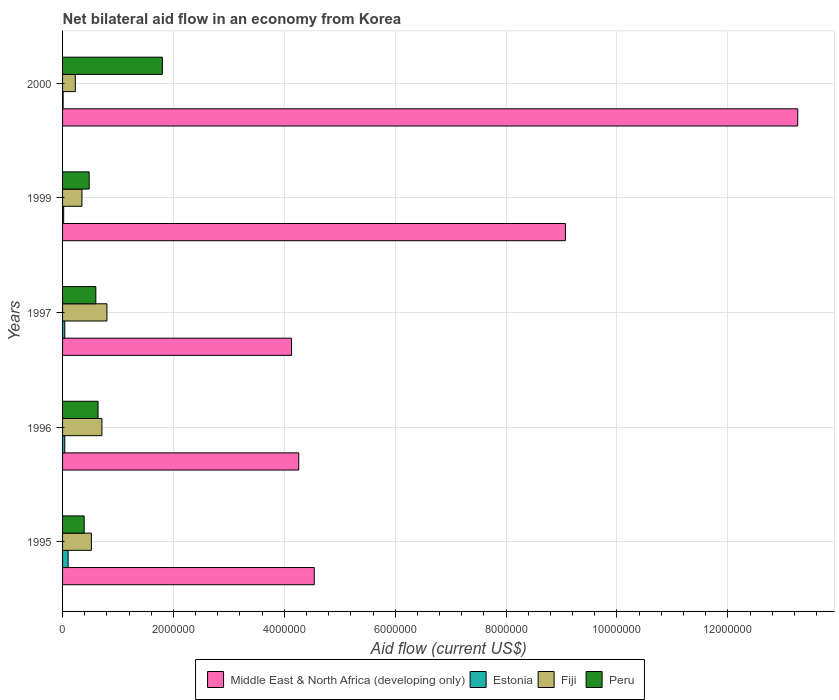How many groups of bars are there?
Your answer should be very brief. 5. Are the number of bars per tick equal to the number of legend labels?
Make the answer very short. Yes. Are the number of bars on each tick of the Y-axis equal?
Your answer should be very brief. Yes. How many bars are there on the 1st tick from the top?
Your answer should be very brief. 4. What is the label of the 4th group of bars from the top?
Keep it short and to the point. 1996. In how many cases, is the number of bars for a given year not equal to the number of legend labels?
Provide a short and direct response. 0. What is the net bilateral aid flow in Estonia in 1997?
Provide a succinct answer. 4.00e+04. Across all years, what is the maximum net bilateral aid flow in Middle East & North Africa (developing only)?
Provide a succinct answer. 1.33e+07. Across all years, what is the minimum net bilateral aid flow in Middle East & North Africa (developing only)?
Your answer should be compact. 4.13e+06. In which year was the net bilateral aid flow in Middle East & North Africa (developing only) maximum?
Provide a short and direct response. 2000. What is the total net bilateral aid flow in Fiji in the graph?
Your response must be concise. 2.61e+06. What is the difference between the net bilateral aid flow in Estonia in 1999 and that in 2000?
Offer a terse response. 10000. What is the difference between the net bilateral aid flow in Middle East & North Africa (developing only) in 2000 and the net bilateral aid flow in Estonia in 1995?
Keep it short and to the point. 1.32e+07. What is the average net bilateral aid flow in Peru per year?
Provide a succinct answer. 7.82e+05. In the year 2000, what is the difference between the net bilateral aid flow in Middle East & North Africa (developing only) and net bilateral aid flow in Estonia?
Offer a terse response. 1.32e+07. What is the ratio of the net bilateral aid flow in Middle East & North Africa (developing only) in 1995 to that in 1997?
Your answer should be very brief. 1.1. What is the difference between the highest and the second highest net bilateral aid flow in Middle East & North Africa (developing only)?
Offer a terse response. 4.19e+06. What is the difference between the highest and the lowest net bilateral aid flow in Middle East & North Africa (developing only)?
Offer a terse response. 9.13e+06. In how many years, is the net bilateral aid flow in Middle East & North Africa (developing only) greater than the average net bilateral aid flow in Middle East & North Africa (developing only) taken over all years?
Make the answer very short. 2. Is it the case that in every year, the sum of the net bilateral aid flow in Peru and net bilateral aid flow in Middle East & North Africa (developing only) is greater than the sum of net bilateral aid flow in Fiji and net bilateral aid flow in Estonia?
Offer a very short reply. Yes. What does the 3rd bar from the top in 1995 represents?
Your answer should be very brief. Estonia. What does the 2nd bar from the bottom in 1995 represents?
Offer a very short reply. Estonia. Are all the bars in the graph horizontal?
Your answer should be compact. Yes. What is the difference between two consecutive major ticks on the X-axis?
Your response must be concise. 2.00e+06. Are the values on the major ticks of X-axis written in scientific E-notation?
Offer a very short reply. No. Does the graph contain any zero values?
Give a very brief answer. No. How are the legend labels stacked?
Your response must be concise. Horizontal. What is the title of the graph?
Provide a succinct answer. Net bilateral aid flow in an economy from Korea. Does "Bahamas" appear as one of the legend labels in the graph?
Ensure brevity in your answer.  No. What is the label or title of the Y-axis?
Give a very brief answer. Years. What is the Aid flow (current US$) in Middle East & North Africa (developing only) in 1995?
Keep it short and to the point. 4.54e+06. What is the Aid flow (current US$) in Estonia in 1995?
Give a very brief answer. 1.00e+05. What is the Aid flow (current US$) of Fiji in 1995?
Provide a succinct answer. 5.20e+05. What is the Aid flow (current US$) of Middle East & North Africa (developing only) in 1996?
Offer a terse response. 4.26e+06. What is the Aid flow (current US$) in Estonia in 1996?
Keep it short and to the point. 4.00e+04. What is the Aid flow (current US$) in Fiji in 1996?
Make the answer very short. 7.10e+05. What is the Aid flow (current US$) in Peru in 1996?
Provide a short and direct response. 6.40e+05. What is the Aid flow (current US$) in Middle East & North Africa (developing only) in 1997?
Ensure brevity in your answer.  4.13e+06. What is the Aid flow (current US$) in Estonia in 1997?
Your answer should be very brief. 4.00e+04. What is the Aid flow (current US$) in Middle East & North Africa (developing only) in 1999?
Give a very brief answer. 9.07e+06. What is the Aid flow (current US$) in Estonia in 1999?
Provide a succinct answer. 2.00e+04. What is the Aid flow (current US$) of Fiji in 1999?
Provide a succinct answer. 3.50e+05. What is the Aid flow (current US$) in Middle East & North Africa (developing only) in 2000?
Keep it short and to the point. 1.33e+07. What is the Aid flow (current US$) of Estonia in 2000?
Give a very brief answer. 10000. What is the Aid flow (current US$) of Peru in 2000?
Ensure brevity in your answer.  1.80e+06. Across all years, what is the maximum Aid flow (current US$) of Middle East & North Africa (developing only)?
Your answer should be compact. 1.33e+07. Across all years, what is the maximum Aid flow (current US$) of Peru?
Your answer should be compact. 1.80e+06. Across all years, what is the minimum Aid flow (current US$) of Middle East & North Africa (developing only)?
Offer a terse response. 4.13e+06. Across all years, what is the minimum Aid flow (current US$) in Estonia?
Provide a short and direct response. 10000. What is the total Aid flow (current US$) of Middle East & North Africa (developing only) in the graph?
Keep it short and to the point. 3.53e+07. What is the total Aid flow (current US$) of Estonia in the graph?
Offer a terse response. 2.10e+05. What is the total Aid flow (current US$) in Fiji in the graph?
Provide a succinct answer. 2.61e+06. What is the total Aid flow (current US$) in Peru in the graph?
Provide a succinct answer. 3.91e+06. What is the difference between the Aid flow (current US$) in Middle East & North Africa (developing only) in 1995 and that in 1996?
Your response must be concise. 2.80e+05. What is the difference between the Aid flow (current US$) of Peru in 1995 and that in 1996?
Provide a short and direct response. -2.50e+05. What is the difference between the Aid flow (current US$) in Middle East & North Africa (developing only) in 1995 and that in 1997?
Ensure brevity in your answer.  4.10e+05. What is the difference between the Aid flow (current US$) of Fiji in 1995 and that in 1997?
Provide a succinct answer. -2.80e+05. What is the difference between the Aid flow (current US$) in Middle East & North Africa (developing only) in 1995 and that in 1999?
Give a very brief answer. -4.53e+06. What is the difference between the Aid flow (current US$) in Estonia in 1995 and that in 1999?
Make the answer very short. 8.00e+04. What is the difference between the Aid flow (current US$) of Peru in 1995 and that in 1999?
Keep it short and to the point. -9.00e+04. What is the difference between the Aid flow (current US$) in Middle East & North Africa (developing only) in 1995 and that in 2000?
Give a very brief answer. -8.72e+06. What is the difference between the Aid flow (current US$) of Estonia in 1995 and that in 2000?
Your answer should be compact. 9.00e+04. What is the difference between the Aid flow (current US$) of Peru in 1995 and that in 2000?
Offer a very short reply. -1.41e+06. What is the difference between the Aid flow (current US$) of Middle East & North Africa (developing only) in 1996 and that in 1997?
Keep it short and to the point. 1.30e+05. What is the difference between the Aid flow (current US$) of Estonia in 1996 and that in 1997?
Ensure brevity in your answer.  0. What is the difference between the Aid flow (current US$) in Fiji in 1996 and that in 1997?
Ensure brevity in your answer.  -9.00e+04. What is the difference between the Aid flow (current US$) of Middle East & North Africa (developing only) in 1996 and that in 1999?
Make the answer very short. -4.81e+06. What is the difference between the Aid flow (current US$) of Fiji in 1996 and that in 1999?
Offer a terse response. 3.60e+05. What is the difference between the Aid flow (current US$) in Peru in 1996 and that in 1999?
Provide a short and direct response. 1.60e+05. What is the difference between the Aid flow (current US$) in Middle East & North Africa (developing only) in 1996 and that in 2000?
Give a very brief answer. -9.00e+06. What is the difference between the Aid flow (current US$) in Fiji in 1996 and that in 2000?
Give a very brief answer. 4.80e+05. What is the difference between the Aid flow (current US$) in Peru in 1996 and that in 2000?
Offer a very short reply. -1.16e+06. What is the difference between the Aid flow (current US$) in Middle East & North Africa (developing only) in 1997 and that in 1999?
Your answer should be compact. -4.94e+06. What is the difference between the Aid flow (current US$) in Estonia in 1997 and that in 1999?
Offer a very short reply. 2.00e+04. What is the difference between the Aid flow (current US$) in Peru in 1997 and that in 1999?
Make the answer very short. 1.20e+05. What is the difference between the Aid flow (current US$) of Middle East & North Africa (developing only) in 1997 and that in 2000?
Ensure brevity in your answer.  -9.13e+06. What is the difference between the Aid flow (current US$) in Fiji in 1997 and that in 2000?
Ensure brevity in your answer.  5.70e+05. What is the difference between the Aid flow (current US$) of Peru in 1997 and that in 2000?
Make the answer very short. -1.20e+06. What is the difference between the Aid flow (current US$) in Middle East & North Africa (developing only) in 1999 and that in 2000?
Provide a succinct answer. -4.19e+06. What is the difference between the Aid flow (current US$) of Peru in 1999 and that in 2000?
Offer a very short reply. -1.32e+06. What is the difference between the Aid flow (current US$) of Middle East & North Africa (developing only) in 1995 and the Aid flow (current US$) of Estonia in 1996?
Give a very brief answer. 4.50e+06. What is the difference between the Aid flow (current US$) in Middle East & North Africa (developing only) in 1995 and the Aid flow (current US$) in Fiji in 1996?
Make the answer very short. 3.83e+06. What is the difference between the Aid flow (current US$) in Middle East & North Africa (developing only) in 1995 and the Aid flow (current US$) in Peru in 1996?
Your response must be concise. 3.90e+06. What is the difference between the Aid flow (current US$) of Estonia in 1995 and the Aid flow (current US$) of Fiji in 1996?
Your answer should be very brief. -6.10e+05. What is the difference between the Aid flow (current US$) in Estonia in 1995 and the Aid flow (current US$) in Peru in 1996?
Your response must be concise. -5.40e+05. What is the difference between the Aid flow (current US$) of Middle East & North Africa (developing only) in 1995 and the Aid flow (current US$) of Estonia in 1997?
Provide a short and direct response. 4.50e+06. What is the difference between the Aid flow (current US$) of Middle East & North Africa (developing only) in 1995 and the Aid flow (current US$) of Fiji in 1997?
Provide a short and direct response. 3.74e+06. What is the difference between the Aid flow (current US$) of Middle East & North Africa (developing only) in 1995 and the Aid flow (current US$) of Peru in 1997?
Give a very brief answer. 3.94e+06. What is the difference between the Aid flow (current US$) of Estonia in 1995 and the Aid flow (current US$) of Fiji in 1997?
Make the answer very short. -7.00e+05. What is the difference between the Aid flow (current US$) in Estonia in 1995 and the Aid flow (current US$) in Peru in 1997?
Give a very brief answer. -5.00e+05. What is the difference between the Aid flow (current US$) in Fiji in 1995 and the Aid flow (current US$) in Peru in 1997?
Make the answer very short. -8.00e+04. What is the difference between the Aid flow (current US$) of Middle East & North Africa (developing only) in 1995 and the Aid flow (current US$) of Estonia in 1999?
Make the answer very short. 4.52e+06. What is the difference between the Aid flow (current US$) of Middle East & North Africa (developing only) in 1995 and the Aid flow (current US$) of Fiji in 1999?
Your response must be concise. 4.19e+06. What is the difference between the Aid flow (current US$) in Middle East & North Africa (developing only) in 1995 and the Aid flow (current US$) in Peru in 1999?
Your answer should be compact. 4.06e+06. What is the difference between the Aid flow (current US$) of Estonia in 1995 and the Aid flow (current US$) of Peru in 1999?
Provide a succinct answer. -3.80e+05. What is the difference between the Aid flow (current US$) in Middle East & North Africa (developing only) in 1995 and the Aid flow (current US$) in Estonia in 2000?
Give a very brief answer. 4.53e+06. What is the difference between the Aid flow (current US$) of Middle East & North Africa (developing only) in 1995 and the Aid flow (current US$) of Fiji in 2000?
Provide a short and direct response. 4.31e+06. What is the difference between the Aid flow (current US$) of Middle East & North Africa (developing only) in 1995 and the Aid flow (current US$) of Peru in 2000?
Your answer should be compact. 2.74e+06. What is the difference between the Aid flow (current US$) in Estonia in 1995 and the Aid flow (current US$) in Peru in 2000?
Offer a terse response. -1.70e+06. What is the difference between the Aid flow (current US$) in Fiji in 1995 and the Aid flow (current US$) in Peru in 2000?
Your answer should be very brief. -1.28e+06. What is the difference between the Aid flow (current US$) of Middle East & North Africa (developing only) in 1996 and the Aid flow (current US$) of Estonia in 1997?
Your answer should be compact. 4.22e+06. What is the difference between the Aid flow (current US$) in Middle East & North Africa (developing only) in 1996 and the Aid flow (current US$) in Fiji in 1997?
Keep it short and to the point. 3.46e+06. What is the difference between the Aid flow (current US$) of Middle East & North Africa (developing only) in 1996 and the Aid flow (current US$) of Peru in 1997?
Give a very brief answer. 3.66e+06. What is the difference between the Aid flow (current US$) in Estonia in 1996 and the Aid flow (current US$) in Fiji in 1997?
Your answer should be very brief. -7.60e+05. What is the difference between the Aid flow (current US$) in Estonia in 1996 and the Aid flow (current US$) in Peru in 1997?
Provide a succinct answer. -5.60e+05. What is the difference between the Aid flow (current US$) in Fiji in 1996 and the Aid flow (current US$) in Peru in 1997?
Ensure brevity in your answer.  1.10e+05. What is the difference between the Aid flow (current US$) in Middle East & North Africa (developing only) in 1996 and the Aid flow (current US$) in Estonia in 1999?
Give a very brief answer. 4.24e+06. What is the difference between the Aid flow (current US$) in Middle East & North Africa (developing only) in 1996 and the Aid flow (current US$) in Fiji in 1999?
Offer a terse response. 3.91e+06. What is the difference between the Aid flow (current US$) of Middle East & North Africa (developing only) in 1996 and the Aid flow (current US$) of Peru in 1999?
Provide a succinct answer. 3.78e+06. What is the difference between the Aid flow (current US$) in Estonia in 1996 and the Aid flow (current US$) in Fiji in 1999?
Provide a short and direct response. -3.10e+05. What is the difference between the Aid flow (current US$) of Estonia in 1996 and the Aid flow (current US$) of Peru in 1999?
Keep it short and to the point. -4.40e+05. What is the difference between the Aid flow (current US$) of Middle East & North Africa (developing only) in 1996 and the Aid flow (current US$) of Estonia in 2000?
Offer a terse response. 4.25e+06. What is the difference between the Aid flow (current US$) in Middle East & North Africa (developing only) in 1996 and the Aid flow (current US$) in Fiji in 2000?
Your response must be concise. 4.03e+06. What is the difference between the Aid flow (current US$) of Middle East & North Africa (developing only) in 1996 and the Aid flow (current US$) of Peru in 2000?
Your answer should be compact. 2.46e+06. What is the difference between the Aid flow (current US$) of Estonia in 1996 and the Aid flow (current US$) of Fiji in 2000?
Your response must be concise. -1.90e+05. What is the difference between the Aid flow (current US$) in Estonia in 1996 and the Aid flow (current US$) in Peru in 2000?
Give a very brief answer. -1.76e+06. What is the difference between the Aid flow (current US$) of Fiji in 1996 and the Aid flow (current US$) of Peru in 2000?
Your answer should be very brief. -1.09e+06. What is the difference between the Aid flow (current US$) in Middle East & North Africa (developing only) in 1997 and the Aid flow (current US$) in Estonia in 1999?
Offer a very short reply. 4.11e+06. What is the difference between the Aid flow (current US$) in Middle East & North Africa (developing only) in 1997 and the Aid flow (current US$) in Fiji in 1999?
Provide a short and direct response. 3.78e+06. What is the difference between the Aid flow (current US$) of Middle East & North Africa (developing only) in 1997 and the Aid flow (current US$) of Peru in 1999?
Give a very brief answer. 3.65e+06. What is the difference between the Aid flow (current US$) in Estonia in 1997 and the Aid flow (current US$) in Fiji in 1999?
Provide a short and direct response. -3.10e+05. What is the difference between the Aid flow (current US$) of Estonia in 1997 and the Aid flow (current US$) of Peru in 1999?
Provide a short and direct response. -4.40e+05. What is the difference between the Aid flow (current US$) in Fiji in 1997 and the Aid flow (current US$) in Peru in 1999?
Your response must be concise. 3.20e+05. What is the difference between the Aid flow (current US$) of Middle East & North Africa (developing only) in 1997 and the Aid flow (current US$) of Estonia in 2000?
Provide a short and direct response. 4.12e+06. What is the difference between the Aid flow (current US$) in Middle East & North Africa (developing only) in 1997 and the Aid flow (current US$) in Fiji in 2000?
Your answer should be compact. 3.90e+06. What is the difference between the Aid flow (current US$) of Middle East & North Africa (developing only) in 1997 and the Aid flow (current US$) of Peru in 2000?
Make the answer very short. 2.33e+06. What is the difference between the Aid flow (current US$) in Estonia in 1997 and the Aid flow (current US$) in Peru in 2000?
Provide a succinct answer. -1.76e+06. What is the difference between the Aid flow (current US$) in Middle East & North Africa (developing only) in 1999 and the Aid flow (current US$) in Estonia in 2000?
Keep it short and to the point. 9.06e+06. What is the difference between the Aid flow (current US$) in Middle East & North Africa (developing only) in 1999 and the Aid flow (current US$) in Fiji in 2000?
Your answer should be very brief. 8.84e+06. What is the difference between the Aid flow (current US$) of Middle East & North Africa (developing only) in 1999 and the Aid flow (current US$) of Peru in 2000?
Provide a succinct answer. 7.27e+06. What is the difference between the Aid flow (current US$) in Estonia in 1999 and the Aid flow (current US$) in Peru in 2000?
Your response must be concise. -1.78e+06. What is the difference between the Aid flow (current US$) of Fiji in 1999 and the Aid flow (current US$) of Peru in 2000?
Ensure brevity in your answer.  -1.45e+06. What is the average Aid flow (current US$) of Middle East & North Africa (developing only) per year?
Give a very brief answer. 7.05e+06. What is the average Aid flow (current US$) of Estonia per year?
Offer a very short reply. 4.20e+04. What is the average Aid flow (current US$) of Fiji per year?
Make the answer very short. 5.22e+05. What is the average Aid flow (current US$) in Peru per year?
Your response must be concise. 7.82e+05. In the year 1995, what is the difference between the Aid flow (current US$) of Middle East & North Africa (developing only) and Aid flow (current US$) of Estonia?
Provide a short and direct response. 4.44e+06. In the year 1995, what is the difference between the Aid flow (current US$) of Middle East & North Africa (developing only) and Aid flow (current US$) of Fiji?
Offer a very short reply. 4.02e+06. In the year 1995, what is the difference between the Aid flow (current US$) in Middle East & North Africa (developing only) and Aid flow (current US$) in Peru?
Give a very brief answer. 4.15e+06. In the year 1995, what is the difference between the Aid flow (current US$) in Estonia and Aid flow (current US$) in Fiji?
Ensure brevity in your answer.  -4.20e+05. In the year 1996, what is the difference between the Aid flow (current US$) of Middle East & North Africa (developing only) and Aid flow (current US$) of Estonia?
Offer a terse response. 4.22e+06. In the year 1996, what is the difference between the Aid flow (current US$) of Middle East & North Africa (developing only) and Aid flow (current US$) of Fiji?
Keep it short and to the point. 3.55e+06. In the year 1996, what is the difference between the Aid flow (current US$) in Middle East & North Africa (developing only) and Aid flow (current US$) in Peru?
Make the answer very short. 3.62e+06. In the year 1996, what is the difference between the Aid flow (current US$) of Estonia and Aid flow (current US$) of Fiji?
Ensure brevity in your answer.  -6.70e+05. In the year 1996, what is the difference between the Aid flow (current US$) of Estonia and Aid flow (current US$) of Peru?
Provide a succinct answer. -6.00e+05. In the year 1997, what is the difference between the Aid flow (current US$) in Middle East & North Africa (developing only) and Aid flow (current US$) in Estonia?
Your response must be concise. 4.09e+06. In the year 1997, what is the difference between the Aid flow (current US$) in Middle East & North Africa (developing only) and Aid flow (current US$) in Fiji?
Your answer should be very brief. 3.33e+06. In the year 1997, what is the difference between the Aid flow (current US$) of Middle East & North Africa (developing only) and Aid flow (current US$) of Peru?
Provide a succinct answer. 3.53e+06. In the year 1997, what is the difference between the Aid flow (current US$) in Estonia and Aid flow (current US$) in Fiji?
Make the answer very short. -7.60e+05. In the year 1997, what is the difference between the Aid flow (current US$) in Estonia and Aid flow (current US$) in Peru?
Give a very brief answer. -5.60e+05. In the year 1997, what is the difference between the Aid flow (current US$) of Fiji and Aid flow (current US$) of Peru?
Provide a short and direct response. 2.00e+05. In the year 1999, what is the difference between the Aid flow (current US$) in Middle East & North Africa (developing only) and Aid flow (current US$) in Estonia?
Your answer should be very brief. 9.05e+06. In the year 1999, what is the difference between the Aid flow (current US$) of Middle East & North Africa (developing only) and Aid flow (current US$) of Fiji?
Provide a succinct answer. 8.72e+06. In the year 1999, what is the difference between the Aid flow (current US$) of Middle East & North Africa (developing only) and Aid flow (current US$) of Peru?
Your response must be concise. 8.59e+06. In the year 1999, what is the difference between the Aid flow (current US$) in Estonia and Aid flow (current US$) in Fiji?
Your answer should be very brief. -3.30e+05. In the year 1999, what is the difference between the Aid flow (current US$) of Estonia and Aid flow (current US$) of Peru?
Provide a short and direct response. -4.60e+05. In the year 2000, what is the difference between the Aid flow (current US$) of Middle East & North Africa (developing only) and Aid flow (current US$) of Estonia?
Provide a short and direct response. 1.32e+07. In the year 2000, what is the difference between the Aid flow (current US$) in Middle East & North Africa (developing only) and Aid flow (current US$) in Fiji?
Ensure brevity in your answer.  1.30e+07. In the year 2000, what is the difference between the Aid flow (current US$) in Middle East & North Africa (developing only) and Aid flow (current US$) in Peru?
Give a very brief answer. 1.15e+07. In the year 2000, what is the difference between the Aid flow (current US$) of Estonia and Aid flow (current US$) of Fiji?
Provide a short and direct response. -2.20e+05. In the year 2000, what is the difference between the Aid flow (current US$) in Estonia and Aid flow (current US$) in Peru?
Your response must be concise. -1.79e+06. In the year 2000, what is the difference between the Aid flow (current US$) in Fiji and Aid flow (current US$) in Peru?
Keep it short and to the point. -1.57e+06. What is the ratio of the Aid flow (current US$) in Middle East & North Africa (developing only) in 1995 to that in 1996?
Your answer should be very brief. 1.07. What is the ratio of the Aid flow (current US$) in Estonia in 1995 to that in 1996?
Ensure brevity in your answer.  2.5. What is the ratio of the Aid flow (current US$) of Fiji in 1995 to that in 1996?
Give a very brief answer. 0.73. What is the ratio of the Aid flow (current US$) in Peru in 1995 to that in 1996?
Give a very brief answer. 0.61. What is the ratio of the Aid flow (current US$) of Middle East & North Africa (developing only) in 1995 to that in 1997?
Offer a very short reply. 1.1. What is the ratio of the Aid flow (current US$) of Fiji in 1995 to that in 1997?
Give a very brief answer. 0.65. What is the ratio of the Aid flow (current US$) in Peru in 1995 to that in 1997?
Give a very brief answer. 0.65. What is the ratio of the Aid flow (current US$) of Middle East & North Africa (developing only) in 1995 to that in 1999?
Your answer should be very brief. 0.5. What is the ratio of the Aid flow (current US$) of Fiji in 1995 to that in 1999?
Make the answer very short. 1.49. What is the ratio of the Aid flow (current US$) of Peru in 1995 to that in 1999?
Your response must be concise. 0.81. What is the ratio of the Aid flow (current US$) of Middle East & North Africa (developing only) in 1995 to that in 2000?
Your response must be concise. 0.34. What is the ratio of the Aid flow (current US$) of Fiji in 1995 to that in 2000?
Offer a terse response. 2.26. What is the ratio of the Aid flow (current US$) of Peru in 1995 to that in 2000?
Offer a very short reply. 0.22. What is the ratio of the Aid flow (current US$) in Middle East & North Africa (developing only) in 1996 to that in 1997?
Make the answer very short. 1.03. What is the ratio of the Aid flow (current US$) of Estonia in 1996 to that in 1997?
Ensure brevity in your answer.  1. What is the ratio of the Aid flow (current US$) of Fiji in 1996 to that in 1997?
Your response must be concise. 0.89. What is the ratio of the Aid flow (current US$) of Peru in 1996 to that in 1997?
Offer a terse response. 1.07. What is the ratio of the Aid flow (current US$) of Middle East & North Africa (developing only) in 1996 to that in 1999?
Provide a short and direct response. 0.47. What is the ratio of the Aid flow (current US$) in Estonia in 1996 to that in 1999?
Your answer should be very brief. 2. What is the ratio of the Aid flow (current US$) in Fiji in 1996 to that in 1999?
Provide a succinct answer. 2.03. What is the ratio of the Aid flow (current US$) in Middle East & North Africa (developing only) in 1996 to that in 2000?
Make the answer very short. 0.32. What is the ratio of the Aid flow (current US$) in Estonia in 1996 to that in 2000?
Your response must be concise. 4. What is the ratio of the Aid flow (current US$) in Fiji in 1996 to that in 2000?
Offer a very short reply. 3.09. What is the ratio of the Aid flow (current US$) of Peru in 1996 to that in 2000?
Provide a succinct answer. 0.36. What is the ratio of the Aid flow (current US$) in Middle East & North Africa (developing only) in 1997 to that in 1999?
Your response must be concise. 0.46. What is the ratio of the Aid flow (current US$) in Estonia in 1997 to that in 1999?
Offer a very short reply. 2. What is the ratio of the Aid flow (current US$) of Fiji in 1997 to that in 1999?
Your answer should be compact. 2.29. What is the ratio of the Aid flow (current US$) of Peru in 1997 to that in 1999?
Your answer should be very brief. 1.25. What is the ratio of the Aid flow (current US$) in Middle East & North Africa (developing only) in 1997 to that in 2000?
Make the answer very short. 0.31. What is the ratio of the Aid flow (current US$) in Fiji in 1997 to that in 2000?
Give a very brief answer. 3.48. What is the ratio of the Aid flow (current US$) of Peru in 1997 to that in 2000?
Offer a very short reply. 0.33. What is the ratio of the Aid flow (current US$) in Middle East & North Africa (developing only) in 1999 to that in 2000?
Ensure brevity in your answer.  0.68. What is the ratio of the Aid flow (current US$) of Fiji in 1999 to that in 2000?
Provide a short and direct response. 1.52. What is the ratio of the Aid flow (current US$) in Peru in 1999 to that in 2000?
Your answer should be very brief. 0.27. What is the difference between the highest and the second highest Aid flow (current US$) in Middle East & North Africa (developing only)?
Ensure brevity in your answer.  4.19e+06. What is the difference between the highest and the second highest Aid flow (current US$) in Fiji?
Your answer should be very brief. 9.00e+04. What is the difference between the highest and the second highest Aid flow (current US$) of Peru?
Offer a very short reply. 1.16e+06. What is the difference between the highest and the lowest Aid flow (current US$) of Middle East & North Africa (developing only)?
Offer a very short reply. 9.13e+06. What is the difference between the highest and the lowest Aid flow (current US$) in Estonia?
Provide a succinct answer. 9.00e+04. What is the difference between the highest and the lowest Aid flow (current US$) of Fiji?
Ensure brevity in your answer.  5.70e+05. What is the difference between the highest and the lowest Aid flow (current US$) in Peru?
Ensure brevity in your answer.  1.41e+06. 